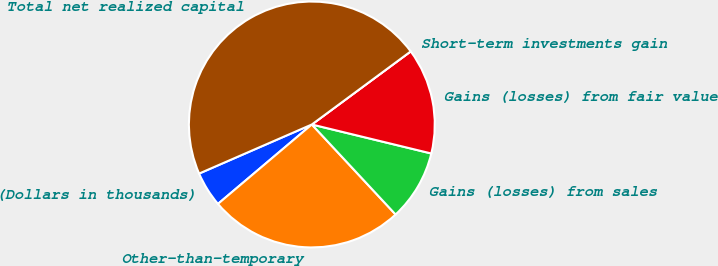Convert chart to OTSL. <chart><loc_0><loc_0><loc_500><loc_500><pie_chart><fcel>(Dollars in thousands)<fcel>Other-than-temporary<fcel>Gains (losses) from sales<fcel>Gains (losses) from fair value<fcel>Short-term investments gain<fcel>Total net realized capital<nl><fcel>4.64%<fcel>25.75%<fcel>9.28%<fcel>13.92%<fcel>0.0%<fcel>46.4%<nl></chart> 